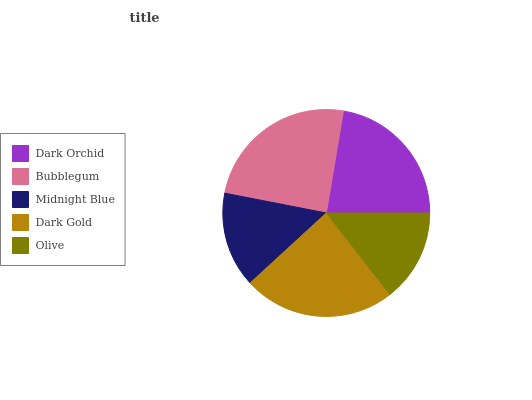Is Olive the minimum?
Answer yes or no. Yes. Is Bubblegum the maximum?
Answer yes or no. Yes. Is Midnight Blue the minimum?
Answer yes or no. No. Is Midnight Blue the maximum?
Answer yes or no. No. Is Bubblegum greater than Midnight Blue?
Answer yes or no. Yes. Is Midnight Blue less than Bubblegum?
Answer yes or no. Yes. Is Midnight Blue greater than Bubblegum?
Answer yes or no. No. Is Bubblegum less than Midnight Blue?
Answer yes or no. No. Is Dark Orchid the high median?
Answer yes or no. Yes. Is Dark Orchid the low median?
Answer yes or no. Yes. Is Olive the high median?
Answer yes or no. No. Is Dark Gold the low median?
Answer yes or no. No. 